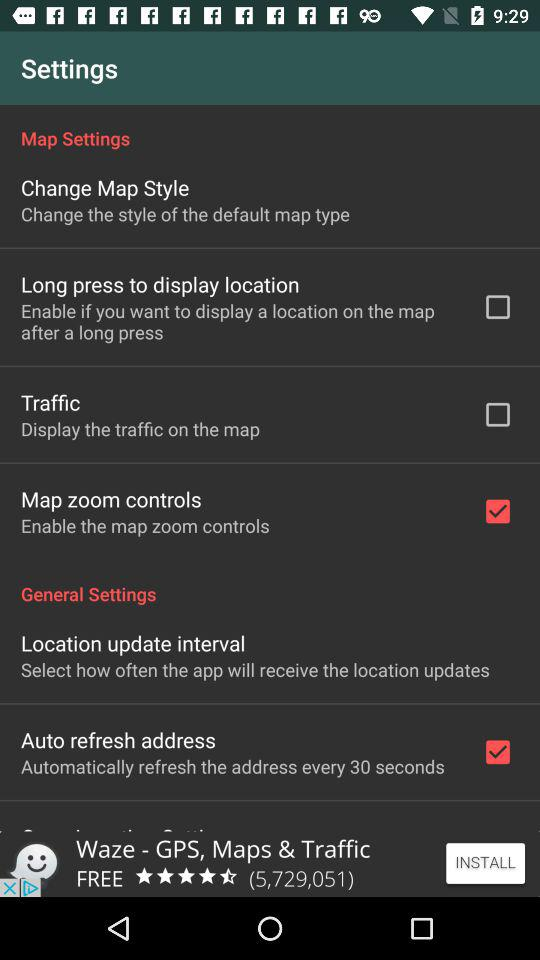Which option is marked as checked? The checked options are "Map zoom controls" and "Auto refresh address". 